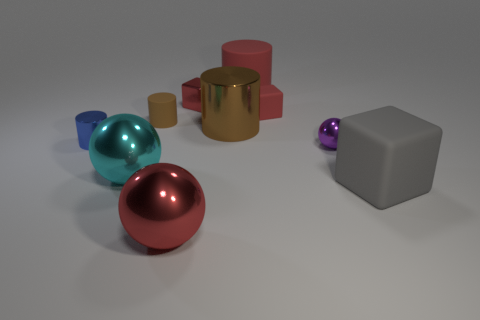Which object in this image appears to be the largest? The largest object in the image appears to be the gray cube on the right side of the array of objects. 